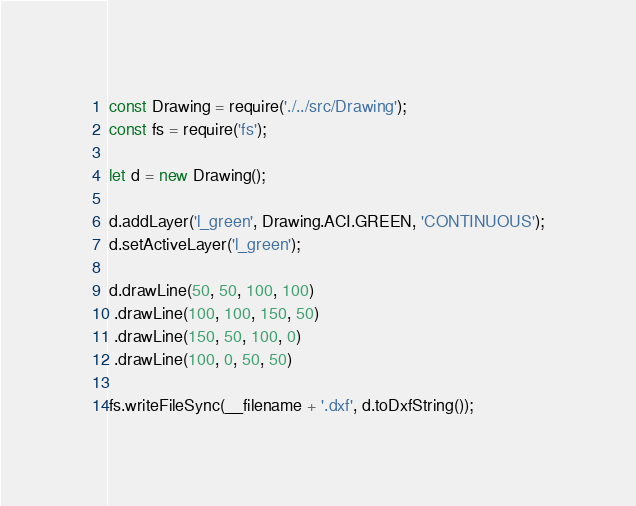<code> <loc_0><loc_0><loc_500><loc_500><_JavaScript_>const Drawing = require('./../src/Drawing');
const fs = require('fs');

let d = new Drawing();

d.addLayer('l_green', Drawing.ACI.GREEN, 'CONTINUOUS');
d.setActiveLayer('l_green');

d.drawLine(50, 50, 100, 100)
 .drawLine(100, 100, 150, 50)
 .drawLine(150, 50, 100, 0)
 .drawLine(100, 0, 50, 50)

fs.writeFileSync(__filename + '.dxf', d.toDxfString());</code> 